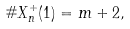<formula> <loc_0><loc_0><loc_500><loc_500>\# X _ { n } ^ { + } ( 1 ) = m + 2 ,</formula> 